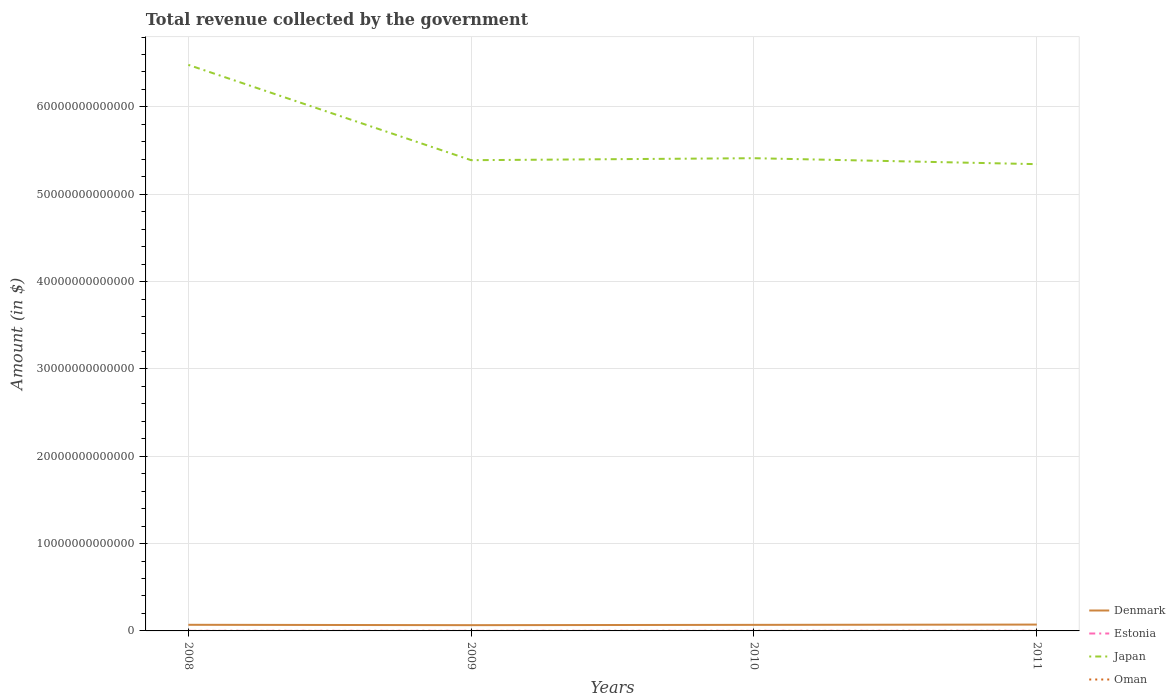How many different coloured lines are there?
Your answer should be compact. 4. Is the number of lines equal to the number of legend labels?
Keep it short and to the point. Yes. Across all years, what is the maximum total revenue collected by the government in Denmark?
Provide a succinct answer. 6.61e+11. In which year was the total revenue collected by the government in Estonia maximum?
Provide a succinct answer. 2010. What is the total total revenue collected by the government in Estonia in the graph?
Give a very brief answer. -3.56e+08. What is the difference between the highest and the second highest total revenue collected by the government in Denmark?
Provide a succinct answer. 6.53e+1. How many lines are there?
Provide a succinct answer. 4. What is the difference between two consecutive major ticks on the Y-axis?
Provide a succinct answer. 1.00e+13. Does the graph contain any zero values?
Give a very brief answer. No. Does the graph contain grids?
Your answer should be very brief. Yes. What is the title of the graph?
Make the answer very short. Total revenue collected by the government. What is the label or title of the X-axis?
Provide a succinct answer. Years. What is the label or title of the Y-axis?
Provide a succinct answer. Amount (in $). What is the Amount (in $) in Denmark in 2008?
Make the answer very short. 7.01e+11. What is the Amount (in $) in Estonia in 2008?
Make the answer very short. 4.98e+09. What is the Amount (in $) in Japan in 2008?
Ensure brevity in your answer.  6.48e+13. What is the Amount (in $) in Oman in 2008?
Provide a short and direct response. 7.56e+09. What is the Amount (in $) in Denmark in 2009?
Offer a very short reply. 6.61e+11. What is the Amount (in $) of Estonia in 2009?
Make the answer very short. 5.06e+09. What is the Amount (in $) in Japan in 2009?
Give a very brief answer. 5.39e+13. What is the Amount (in $) of Oman in 2009?
Your response must be concise. 6.71e+09. What is the Amount (in $) of Denmark in 2010?
Give a very brief answer. 6.95e+11. What is the Amount (in $) of Estonia in 2010?
Provide a succinct answer. 4.96e+09. What is the Amount (in $) of Japan in 2010?
Your answer should be very brief. 5.41e+13. What is the Amount (in $) in Oman in 2010?
Keep it short and to the point. 7.87e+09. What is the Amount (in $) of Denmark in 2011?
Keep it short and to the point. 7.26e+11. What is the Amount (in $) in Estonia in 2011?
Make the answer very short. 5.31e+09. What is the Amount (in $) of Japan in 2011?
Provide a succinct answer. 5.34e+13. What is the Amount (in $) of Oman in 2011?
Your answer should be very brief. 1.06e+1. Across all years, what is the maximum Amount (in $) of Denmark?
Keep it short and to the point. 7.26e+11. Across all years, what is the maximum Amount (in $) of Estonia?
Provide a short and direct response. 5.31e+09. Across all years, what is the maximum Amount (in $) in Japan?
Your answer should be very brief. 6.48e+13. Across all years, what is the maximum Amount (in $) in Oman?
Your answer should be very brief. 1.06e+1. Across all years, what is the minimum Amount (in $) in Denmark?
Your answer should be very brief. 6.61e+11. Across all years, what is the minimum Amount (in $) of Estonia?
Ensure brevity in your answer.  4.96e+09. Across all years, what is the minimum Amount (in $) in Japan?
Give a very brief answer. 5.34e+13. Across all years, what is the minimum Amount (in $) of Oman?
Offer a very short reply. 6.71e+09. What is the total Amount (in $) in Denmark in the graph?
Provide a succinct answer. 2.78e+12. What is the total Amount (in $) of Estonia in the graph?
Your answer should be very brief. 2.03e+1. What is the total Amount (in $) of Japan in the graph?
Provide a short and direct response. 2.26e+14. What is the total Amount (in $) in Oman in the graph?
Provide a short and direct response. 3.27e+1. What is the difference between the Amount (in $) in Denmark in 2008 and that in 2009?
Your response must be concise. 4.04e+1. What is the difference between the Amount (in $) in Estonia in 2008 and that in 2009?
Your answer should be very brief. -7.78e+07. What is the difference between the Amount (in $) of Japan in 2008 and that in 2009?
Your answer should be compact. 1.09e+13. What is the difference between the Amount (in $) of Oman in 2008 and that in 2009?
Ensure brevity in your answer.  8.42e+08. What is the difference between the Amount (in $) in Denmark in 2008 and that in 2010?
Offer a very short reply. 6.20e+09. What is the difference between the Amount (in $) in Estonia in 2008 and that in 2010?
Offer a very short reply. 2.82e+07. What is the difference between the Amount (in $) in Japan in 2008 and that in 2010?
Your answer should be very brief. 1.07e+13. What is the difference between the Amount (in $) of Oman in 2008 and that in 2010?
Your answer should be compact. -3.12e+08. What is the difference between the Amount (in $) of Denmark in 2008 and that in 2011?
Provide a short and direct response. -2.49e+1. What is the difference between the Amount (in $) in Estonia in 2008 and that in 2011?
Give a very brief answer. -3.28e+08. What is the difference between the Amount (in $) in Japan in 2008 and that in 2011?
Provide a short and direct response. 1.14e+13. What is the difference between the Amount (in $) of Oman in 2008 and that in 2011?
Offer a terse response. -3.01e+09. What is the difference between the Amount (in $) of Denmark in 2009 and that in 2010?
Provide a short and direct response. -3.42e+1. What is the difference between the Amount (in $) in Estonia in 2009 and that in 2010?
Ensure brevity in your answer.  1.06e+08. What is the difference between the Amount (in $) in Japan in 2009 and that in 2010?
Your answer should be very brief. -2.27e+11. What is the difference between the Amount (in $) of Oman in 2009 and that in 2010?
Keep it short and to the point. -1.15e+09. What is the difference between the Amount (in $) of Denmark in 2009 and that in 2011?
Ensure brevity in your answer.  -6.53e+1. What is the difference between the Amount (in $) of Estonia in 2009 and that in 2011?
Your response must be concise. -2.50e+08. What is the difference between the Amount (in $) in Japan in 2009 and that in 2011?
Provide a succinct answer. 4.53e+11. What is the difference between the Amount (in $) of Oman in 2009 and that in 2011?
Keep it short and to the point. -3.85e+09. What is the difference between the Amount (in $) of Denmark in 2010 and that in 2011?
Offer a terse response. -3.11e+1. What is the difference between the Amount (in $) in Estonia in 2010 and that in 2011?
Your answer should be compact. -3.56e+08. What is the difference between the Amount (in $) in Japan in 2010 and that in 2011?
Your response must be concise. 6.80e+11. What is the difference between the Amount (in $) in Oman in 2010 and that in 2011?
Provide a succinct answer. -2.70e+09. What is the difference between the Amount (in $) in Denmark in 2008 and the Amount (in $) in Estonia in 2009?
Provide a short and direct response. 6.96e+11. What is the difference between the Amount (in $) in Denmark in 2008 and the Amount (in $) in Japan in 2009?
Offer a terse response. -5.32e+13. What is the difference between the Amount (in $) in Denmark in 2008 and the Amount (in $) in Oman in 2009?
Ensure brevity in your answer.  6.94e+11. What is the difference between the Amount (in $) in Estonia in 2008 and the Amount (in $) in Japan in 2009?
Offer a very short reply. -5.39e+13. What is the difference between the Amount (in $) of Estonia in 2008 and the Amount (in $) of Oman in 2009?
Provide a short and direct response. -1.73e+09. What is the difference between the Amount (in $) of Japan in 2008 and the Amount (in $) of Oman in 2009?
Your answer should be very brief. 6.48e+13. What is the difference between the Amount (in $) in Denmark in 2008 and the Amount (in $) in Estonia in 2010?
Provide a short and direct response. 6.96e+11. What is the difference between the Amount (in $) of Denmark in 2008 and the Amount (in $) of Japan in 2010?
Ensure brevity in your answer.  -5.34e+13. What is the difference between the Amount (in $) of Denmark in 2008 and the Amount (in $) of Oman in 2010?
Offer a very short reply. 6.93e+11. What is the difference between the Amount (in $) in Estonia in 2008 and the Amount (in $) in Japan in 2010?
Provide a succinct answer. -5.41e+13. What is the difference between the Amount (in $) in Estonia in 2008 and the Amount (in $) in Oman in 2010?
Provide a short and direct response. -2.88e+09. What is the difference between the Amount (in $) in Japan in 2008 and the Amount (in $) in Oman in 2010?
Provide a short and direct response. 6.48e+13. What is the difference between the Amount (in $) of Denmark in 2008 and the Amount (in $) of Estonia in 2011?
Offer a terse response. 6.96e+11. What is the difference between the Amount (in $) of Denmark in 2008 and the Amount (in $) of Japan in 2011?
Make the answer very short. -5.27e+13. What is the difference between the Amount (in $) in Denmark in 2008 and the Amount (in $) in Oman in 2011?
Keep it short and to the point. 6.91e+11. What is the difference between the Amount (in $) of Estonia in 2008 and the Amount (in $) of Japan in 2011?
Ensure brevity in your answer.  -5.34e+13. What is the difference between the Amount (in $) in Estonia in 2008 and the Amount (in $) in Oman in 2011?
Give a very brief answer. -5.58e+09. What is the difference between the Amount (in $) in Japan in 2008 and the Amount (in $) in Oman in 2011?
Give a very brief answer. 6.48e+13. What is the difference between the Amount (in $) of Denmark in 2009 and the Amount (in $) of Estonia in 2010?
Your response must be concise. 6.56e+11. What is the difference between the Amount (in $) in Denmark in 2009 and the Amount (in $) in Japan in 2010?
Give a very brief answer. -5.35e+13. What is the difference between the Amount (in $) in Denmark in 2009 and the Amount (in $) in Oman in 2010?
Give a very brief answer. 6.53e+11. What is the difference between the Amount (in $) of Estonia in 2009 and the Amount (in $) of Japan in 2010?
Give a very brief answer. -5.41e+13. What is the difference between the Amount (in $) of Estonia in 2009 and the Amount (in $) of Oman in 2010?
Provide a short and direct response. -2.81e+09. What is the difference between the Amount (in $) in Japan in 2009 and the Amount (in $) in Oman in 2010?
Your response must be concise. 5.39e+13. What is the difference between the Amount (in $) of Denmark in 2009 and the Amount (in $) of Estonia in 2011?
Provide a short and direct response. 6.55e+11. What is the difference between the Amount (in $) in Denmark in 2009 and the Amount (in $) in Japan in 2011?
Offer a terse response. -5.28e+13. What is the difference between the Amount (in $) of Denmark in 2009 and the Amount (in $) of Oman in 2011?
Provide a short and direct response. 6.50e+11. What is the difference between the Amount (in $) of Estonia in 2009 and the Amount (in $) of Japan in 2011?
Give a very brief answer. -5.34e+13. What is the difference between the Amount (in $) of Estonia in 2009 and the Amount (in $) of Oman in 2011?
Provide a short and direct response. -5.51e+09. What is the difference between the Amount (in $) of Japan in 2009 and the Amount (in $) of Oman in 2011?
Make the answer very short. 5.39e+13. What is the difference between the Amount (in $) of Denmark in 2010 and the Amount (in $) of Estonia in 2011?
Your answer should be very brief. 6.90e+11. What is the difference between the Amount (in $) of Denmark in 2010 and the Amount (in $) of Japan in 2011?
Provide a succinct answer. -5.27e+13. What is the difference between the Amount (in $) of Denmark in 2010 and the Amount (in $) of Oman in 2011?
Offer a very short reply. 6.84e+11. What is the difference between the Amount (in $) of Estonia in 2010 and the Amount (in $) of Japan in 2011?
Make the answer very short. -5.34e+13. What is the difference between the Amount (in $) of Estonia in 2010 and the Amount (in $) of Oman in 2011?
Ensure brevity in your answer.  -5.61e+09. What is the difference between the Amount (in $) in Japan in 2010 and the Amount (in $) in Oman in 2011?
Offer a very short reply. 5.41e+13. What is the average Amount (in $) in Denmark per year?
Your response must be concise. 6.96e+11. What is the average Amount (in $) of Estonia per year?
Ensure brevity in your answer.  5.08e+09. What is the average Amount (in $) in Japan per year?
Provide a short and direct response. 5.66e+13. What is the average Amount (in $) of Oman per year?
Your answer should be very brief. 8.18e+09. In the year 2008, what is the difference between the Amount (in $) in Denmark and Amount (in $) in Estonia?
Make the answer very short. 6.96e+11. In the year 2008, what is the difference between the Amount (in $) in Denmark and Amount (in $) in Japan?
Offer a terse response. -6.41e+13. In the year 2008, what is the difference between the Amount (in $) in Denmark and Amount (in $) in Oman?
Your response must be concise. 6.94e+11. In the year 2008, what is the difference between the Amount (in $) of Estonia and Amount (in $) of Japan?
Offer a very short reply. -6.48e+13. In the year 2008, what is the difference between the Amount (in $) of Estonia and Amount (in $) of Oman?
Your answer should be very brief. -2.57e+09. In the year 2008, what is the difference between the Amount (in $) of Japan and Amount (in $) of Oman?
Give a very brief answer. 6.48e+13. In the year 2009, what is the difference between the Amount (in $) in Denmark and Amount (in $) in Estonia?
Give a very brief answer. 6.56e+11. In the year 2009, what is the difference between the Amount (in $) in Denmark and Amount (in $) in Japan?
Give a very brief answer. -5.32e+13. In the year 2009, what is the difference between the Amount (in $) in Denmark and Amount (in $) in Oman?
Ensure brevity in your answer.  6.54e+11. In the year 2009, what is the difference between the Amount (in $) of Estonia and Amount (in $) of Japan?
Ensure brevity in your answer.  -5.39e+13. In the year 2009, what is the difference between the Amount (in $) in Estonia and Amount (in $) in Oman?
Give a very brief answer. -1.65e+09. In the year 2009, what is the difference between the Amount (in $) of Japan and Amount (in $) of Oman?
Give a very brief answer. 5.39e+13. In the year 2010, what is the difference between the Amount (in $) in Denmark and Amount (in $) in Estonia?
Your answer should be very brief. 6.90e+11. In the year 2010, what is the difference between the Amount (in $) in Denmark and Amount (in $) in Japan?
Your response must be concise. -5.34e+13. In the year 2010, what is the difference between the Amount (in $) in Denmark and Amount (in $) in Oman?
Make the answer very short. 6.87e+11. In the year 2010, what is the difference between the Amount (in $) in Estonia and Amount (in $) in Japan?
Offer a very short reply. -5.41e+13. In the year 2010, what is the difference between the Amount (in $) of Estonia and Amount (in $) of Oman?
Provide a succinct answer. -2.91e+09. In the year 2010, what is the difference between the Amount (in $) in Japan and Amount (in $) in Oman?
Offer a terse response. 5.41e+13. In the year 2011, what is the difference between the Amount (in $) in Denmark and Amount (in $) in Estonia?
Give a very brief answer. 7.21e+11. In the year 2011, what is the difference between the Amount (in $) in Denmark and Amount (in $) in Japan?
Your answer should be compact. -5.27e+13. In the year 2011, what is the difference between the Amount (in $) of Denmark and Amount (in $) of Oman?
Ensure brevity in your answer.  7.15e+11. In the year 2011, what is the difference between the Amount (in $) of Estonia and Amount (in $) of Japan?
Your answer should be very brief. -5.34e+13. In the year 2011, what is the difference between the Amount (in $) of Estonia and Amount (in $) of Oman?
Make the answer very short. -5.26e+09. In the year 2011, what is the difference between the Amount (in $) in Japan and Amount (in $) in Oman?
Offer a very short reply. 5.34e+13. What is the ratio of the Amount (in $) of Denmark in 2008 to that in 2009?
Ensure brevity in your answer.  1.06. What is the ratio of the Amount (in $) of Estonia in 2008 to that in 2009?
Offer a terse response. 0.98. What is the ratio of the Amount (in $) of Japan in 2008 to that in 2009?
Your response must be concise. 1.2. What is the ratio of the Amount (in $) in Oman in 2008 to that in 2009?
Your response must be concise. 1.13. What is the ratio of the Amount (in $) of Denmark in 2008 to that in 2010?
Make the answer very short. 1.01. What is the ratio of the Amount (in $) in Estonia in 2008 to that in 2010?
Ensure brevity in your answer.  1.01. What is the ratio of the Amount (in $) of Japan in 2008 to that in 2010?
Offer a terse response. 1.2. What is the ratio of the Amount (in $) in Oman in 2008 to that in 2010?
Your answer should be compact. 0.96. What is the ratio of the Amount (in $) of Denmark in 2008 to that in 2011?
Make the answer very short. 0.97. What is the ratio of the Amount (in $) in Estonia in 2008 to that in 2011?
Your response must be concise. 0.94. What is the ratio of the Amount (in $) of Japan in 2008 to that in 2011?
Your answer should be very brief. 1.21. What is the ratio of the Amount (in $) in Oman in 2008 to that in 2011?
Offer a terse response. 0.71. What is the ratio of the Amount (in $) in Denmark in 2009 to that in 2010?
Your answer should be very brief. 0.95. What is the ratio of the Amount (in $) in Estonia in 2009 to that in 2010?
Offer a very short reply. 1.02. What is the ratio of the Amount (in $) of Japan in 2009 to that in 2010?
Make the answer very short. 1. What is the ratio of the Amount (in $) of Oman in 2009 to that in 2010?
Make the answer very short. 0.85. What is the ratio of the Amount (in $) of Denmark in 2009 to that in 2011?
Provide a short and direct response. 0.91. What is the ratio of the Amount (in $) of Estonia in 2009 to that in 2011?
Provide a succinct answer. 0.95. What is the ratio of the Amount (in $) of Japan in 2009 to that in 2011?
Your answer should be very brief. 1.01. What is the ratio of the Amount (in $) in Oman in 2009 to that in 2011?
Your answer should be compact. 0.64. What is the ratio of the Amount (in $) in Denmark in 2010 to that in 2011?
Ensure brevity in your answer.  0.96. What is the ratio of the Amount (in $) in Estonia in 2010 to that in 2011?
Offer a very short reply. 0.93. What is the ratio of the Amount (in $) in Japan in 2010 to that in 2011?
Provide a short and direct response. 1.01. What is the ratio of the Amount (in $) of Oman in 2010 to that in 2011?
Make the answer very short. 0.74. What is the difference between the highest and the second highest Amount (in $) of Denmark?
Your answer should be very brief. 2.49e+1. What is the difference between the highest and the second highest Amount (in $) in Estonia?
Ensure brevity in your answer.  2.50e+08. What is the difference between the highest and the second highest Amount (in $) of Japan?
Provide a short and direct response. 1.07e+13. What is the difference between the highest and the second highest Amount (in $) of Oman?
Provide a short and direct response. 2.70e+09. What is the difference between the highest and the lowest Amount (in $) in Denmark?
Offer a very short reply. 6.53e+1. What is the difference between the highest and the lowest Amount (in $) of Estonia?
Make the answer very short. 3.56e+08. What is the difference between the highest and the lowest Amount (in $) in Japan?
Provide a succinct answer. 1.14e+13. What is the difference between the highest and the lowest Amount (in $) in Oman?
Your answer should be compact. 3.85e+09. 